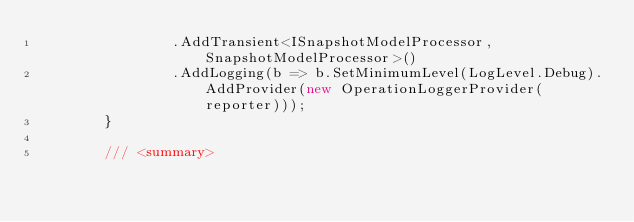<code> <loc_0><loc_0><loc_500><loc_500><_C#_>                .AddTransient<ISnapshotModelProcessor, SnapshotModelProcessor>()
                .AddLogging(b => b.SetMinimumLevel(LogLevel.Debug).AddProvider(new OperationLoggerProvider(reporter)));
        }

        /// <summary></code> 